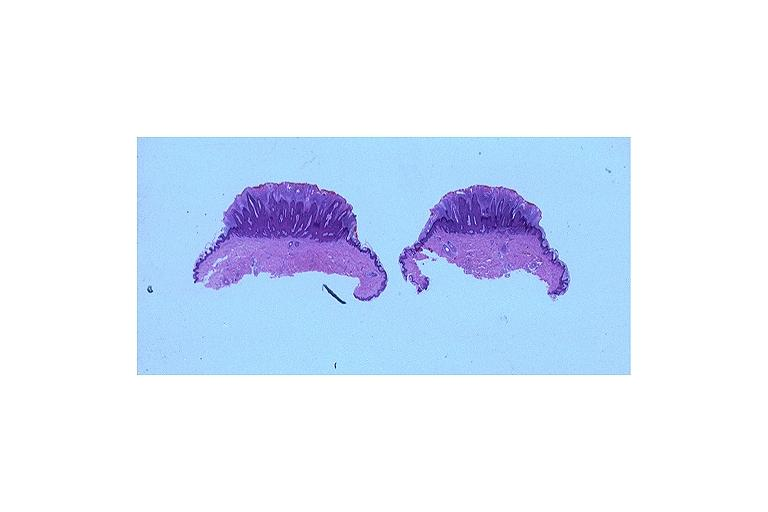does this image show verruca vulgaris?
Answer the question using a single word or phrase. Yes 